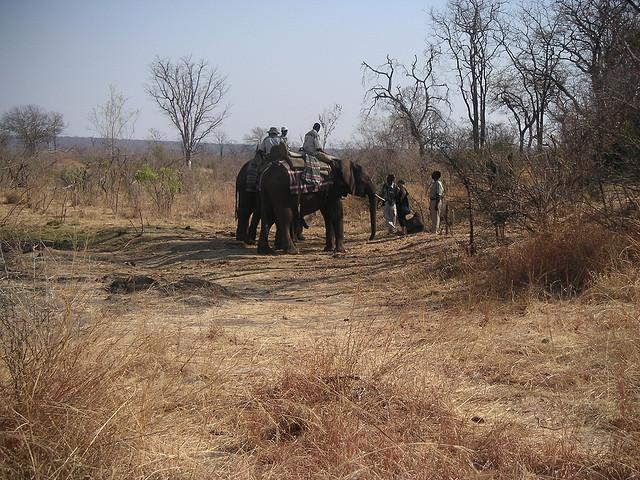What color are the leaves of the tree?
Be succinct. Brown. How many elephants are there?
Keep it brief. 2. How many people can fit on this elephant?
Quick response, please. 2. Is the elephant in water?
Quick response, please. No. Where is this?
Write a very short answer. Africa. Is this scene "dry"?
Write a very short answer. Yes. How many elephant are there?
Write a very short answer. 2. How many people are riding the elephant?
Answer briefly. 3. Can you see green in the picture?
Answer briefly. Yes. How many elephants are in the photo?
Write a very short answer. 2. Is there a swimming pool nearby?
Concise answer only. No. What are these animals?
Quick response, please. Elephants. See any smoke?
Short answer required. No. What color is the train primarily?
Quick response, please. No train. Is the elephant heading towards the camera?
Short answer required. No. What is the color of the grass?
Give a very brief answer. Brown. 